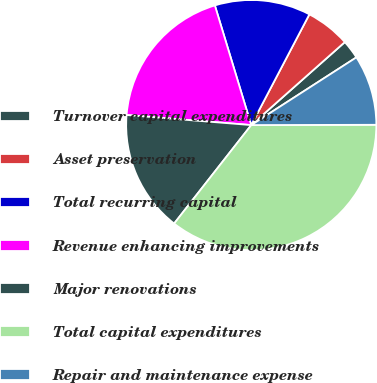Convert chart to OTSL. <chart><loc_0><loc_0><loc_500><loc_500><pie_chart><fcel>Turnover capital expenditures<fcel>Asset preservation<fcel>Total recurring capital<fcel>Revenue enhancing improvements<fcel>Major renovations<fcel>Total capital expenditures<fcel>Repair and maintenance expense<nl><fcel>2.44%<fcel>5.76%<fcel>12.39%<fcel>19.02%<fcel>15.71%<fcel>35.61%<fcel>9.07%<nl></chart> 